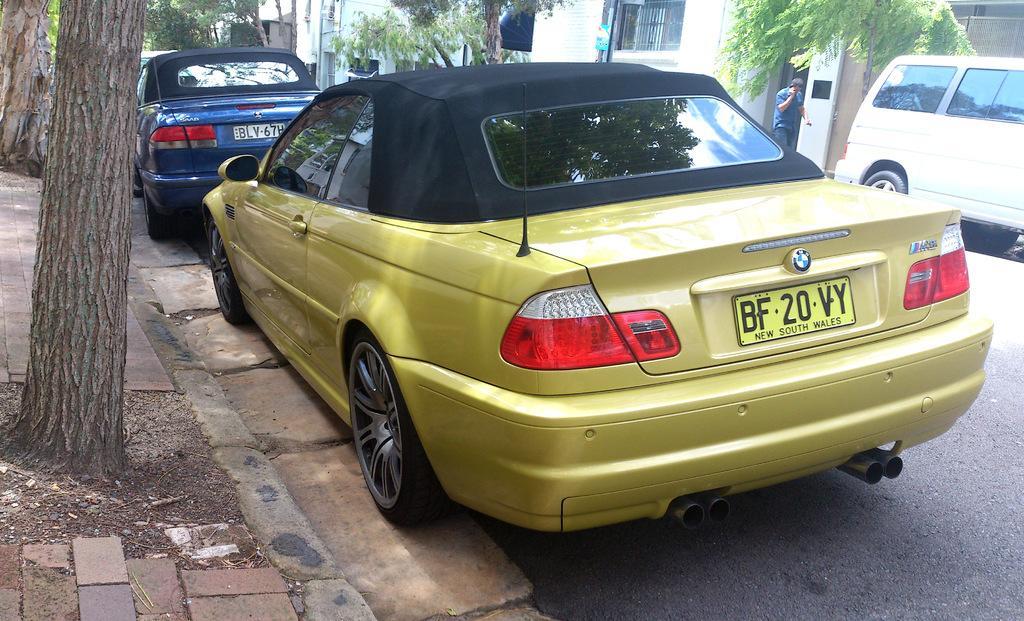How would you summarize this image in a sentence or two? In this image I can see vehicles on the road. In the background I can see a person, trees and buildings. 